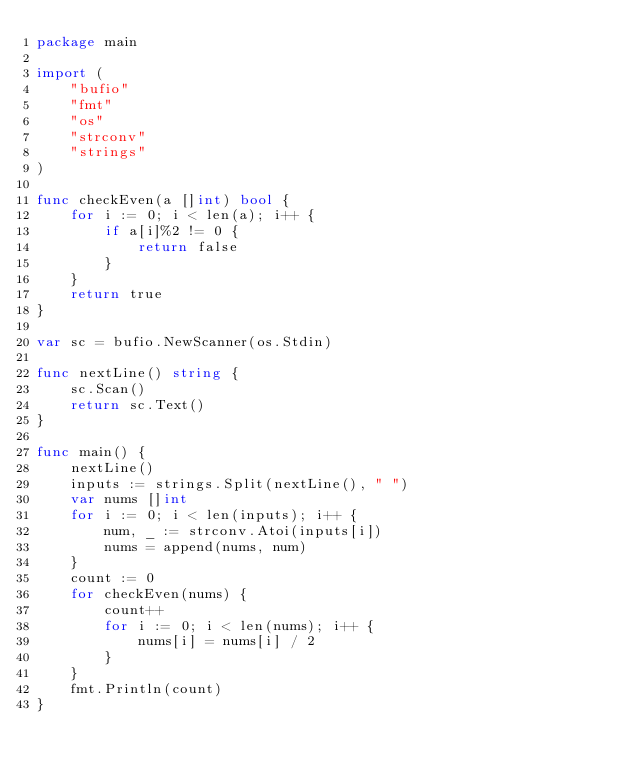<code> <loc_0><loc_0><loc_500><loc_500><_Go_>package main

import (
    "bufio"
    "fmt"
    "os"
    "strconv"
    "strings"
)

func checkEven(a []int) bool {
    for i := 0; i < len(a); i++ {
        if a[i]%2 != 0 {
            return false
        }
    }
    return true
}

var sc = bufio.NewScanner(os.Stdin)

func nextLine() string {
    sc.Scan()
    return sc.Text()
}

func main() {
    nextLine()
    inputs := strings.Split(nextLine(), " ")
    var nums []int
    for i := 0; i < len(inputs); i++ {
        num, _ := strconv.Atoi(inputs[i])
        nums = append(nums, num)
    }
    count := 0
    for checkEven(nums) {
        count++
        for i := 0; i < len(nums); i++ {
            nums[i] = nums[i] / 2
        }
    }
    fmt.Println(count)
}</code> 